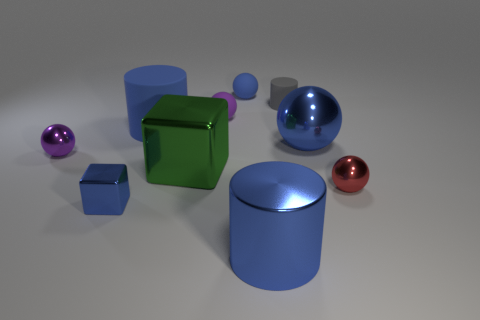Which objects are closest to the front in this arrangement, and what are their colors? The objects closest to the forefront are a glossy purple sphere and a red sphere, whose vivid colors draw attention amidst the more subdued shades of the other elements in the composition. 